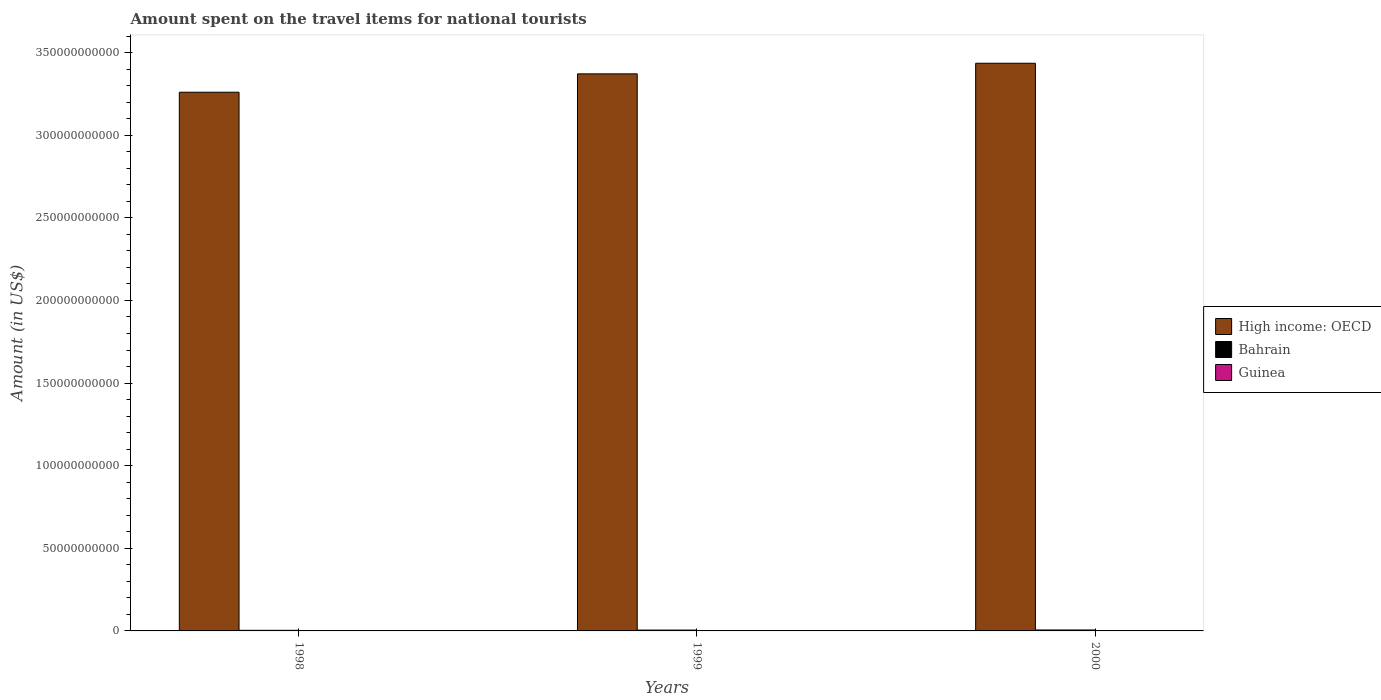How many different coloured bars are there?
Offer a terse response. 3. Are the number of bars per tick equal to the number of legend labels?
Your response must be concise. Yes. Are the number of bars on each tick of the X-axis equal?
Provide a short and direct response. Yes. In how many cases, is the number of bars for a given year not equal to the number of legend labels?
Offer a terse response. 0. What is the amount spent on the travel items for national tourists in Bahrain in 1999?
Ensure brevity in your answer.  5.18e+08. Across all years, what is the maximum amount spent on the travel items for national tourists in Guinea?
Give a very brief answer. 2.00e+06. What is the total amount spent on the travel items for national tourists in Bahrain in the graph?
Provide a short and direct response. 1.46e+09. What is the difference between the amount spent on the travel items for national tourists in Bahrain in 1999 and that in 2000?
Ensure brevity in your answer.  -5.50e+07. What is the difference between the amount spent on the travel items for national tourists in Bahrain in 2000 and the amount spent on the travel items for national tourists in Guinea in 1999?
Offer a terse response. 5.71e+08. What is the average amount spent on the travel items for national tourists in Bahrain per year?
Provide a succinct answer. 4.86e+08. In the year 1998, what is the difference between the amount spent on the travel items for national tourists in Guinea and amount spent on the travel items for national tourists in Bahrain?
Keep it short and to the point. -3.65e+08. In how many years, is the amount spent on the travel items for national tourists in High income: OECD greater than 300000000000 US$?
Keep it short and to the point. 3. What is the ratio of the amount spent on the travel items for national tourists in Bahrain in 1999 to that in 2000?
Keep it short and to the point. 0.9. What is the difference between the highest and the second highest amount spent on the travel items for national tourists in High income: OECD?
Offer a terse response. 6.42e+09. What is the difference between the highest and the lowest amount spent on the travel items for national tourists in Bahrain?
Provide a succinct answer. 2.07e+08. In how many years, is the amount spent on the travel items for national tourists in Guinea greater than the average amount spent on the travel items for national tourists in Guinea taken over all years?
Offer a very short reply. 2. What does the 1st bar from the left in 1999 represents?
Keep it short and to the point. High income: OECD. What does the 1st bar from the right in 2000 represents?
Your answer should be compact. Guinea. Is it the case that in every year, the sum of the amount spent on the travel items for national tourists in Guinea and amount spent on the travel items for national tourists in High income: OECD is greater than the amount spent on the travel items for national tourists in Bahrain?
Offer a terse response. Yes. How many bars are there?
Your response must be concise. 9. Are all the bars in the graph horizontal?
Offer a very short reply. No. How many years are there in the graph?
Keep it short and to the point. 3. What is the difference between two consecutive major ticks on the Y-axis?
Offer a very short reply. 5.00e+1. Are the values on the major ticks of Y-axis written in scientific E-notation?
Ensure brevity in your answer.  No. Does the graph contain any zero values?
Ensure brevity in your answer.  No. Does the graph contain grids?
Provide a succinct answer. No. How many legend labels are there?
Ensure brevity in your answer.  3. What is the title of the graph?
Your answer should be very brief. Amount spent on the travel items for national tourists. Does "Cabo Verde" appear as one of the legend labels in the graph?
Ensure brevity in your answer.  No. What is the label or title of the X-axis?
Ensure brevity in your answer.  Years. What is the Amount (in US$) in High income: OECD in 1998?
Offer a very short reply. 3.26e+11. What is the Amount (in US$) of Bahrain in 1998?
Offer a very short reply. 3.66e+08. What is the Amount (in US$) of High income: OECD in 1999?
Ensure brevity in your answer.  3.37e+11. What is the Amount (in US$) of Bahrain in 1999?
Provide a short and direct response. 5.18e+08. What is the Amount (in US$) of Guinea in 1999?
Offer a very short reply. 1.70e+06. What is the Amount (in US$) in High income: OECD in 2000?
Keep it short and to the point. 3.44e+11. What is the Amount (in US$) in Bahrain in 2000?
Offer a terse response. 5.73e+08. Across all years, what is the maximum Amount (in US$) in High income: OECD?
Your answer should be compact. 3.44e+11. Across all years, what is the maximum Amount (in US$) of Bahrain?
Offer a very short reply. 5.73e+08. Across all years, what is the maximum Amount (in US$) of Guinea?
Offer a very short reply. 2.00e+06. Across all years, what is the minimum Amount (in US$) of High income: OECD?
Provide a succinct answer. 3.26e+11. Across all years, what is the minimum Amount (in US$) of Bahrain?
Ensure brevity in your answer.  3.66e+08. Across all years, what is the minimum Amount (in US$) in Guinea?
Offer a terse response. 9.00e+05. What is the total Amount (in US$) in High income: OECD in the graph?
Keep it short and to the point. 1.01e+12. What is the total Amount (in US$) of Bahrain in the graph?
Offer a terse response. 1.46e+09. What is the total Amount (in US$) of Guinea in the graph?
Offer a terse response. 4.60e+06. What is the difference between the Amount (in US$) of High income: OECD in 1998 and that in 1999?
Provide a short and direct response. -1.11e+1. What is the difference between the Amount (in US$) in Bahrain in 1998 and that in 1999?
Give a very brief answer. -1.52e+08. What is the difference between the Amount (in US$) of Guinea in 1998 and that in 1999?
Offer a very short reply. -8.00e+05. What is the difference between the Amount (in US$) of High income: OECD in 1998 and that in 2000?
Provide a short and direct response. -1.75e+1. What is the difference between the Amount (in US$) in Bahrain in 1998 and that in 2000?
Provide a succinct answer. -2.07e+08. What is the difference between the Amount (in US$) in Guinea in 1998 and that in 2000?
Offer a terse response. -1.10e+06. What is the difference between the Amount (in US$) in High income: OECD in 1999 and that in 2000?
Your response must be concise. -6.42e+09. What is the difference between the Amount (in US$) in Bahrain in 1999 and that in 2000?
Keep it short and to the point. -5.50e+07. What is the difference between the Amount (in US$) of Guinea in 1999 and that in 2000?
Make the answer very short. -3.00e+05. What is the difference between the Amount (in US$) of High income: OECD in 1998 and the Amount (in US$) of Bahrain in 1999?
Make the answer very short. 3.25e+11. What is the difference between the Amount (in US$) of High income: OECD in 1998 and the Amount (in US$) of Guinea in 1999?
Provide a succinct answer. 3.26e+11. What is the difference between the Amount (in US$) of Bahrain in 1998 and the Amount (in US$) of Guinea in 1999?
Offer a very short reply. 3.64e+08. What is the difference between the Amount (in US$) of High income: OECD in 1998 and the Amount (in US$) of Bahrain in 2000?
Give a very brief answer. 3.25e+11. What is the difference between the Amount (in US$) of High income: OECD in 1998 and the Amount (in US$) of Guinea in 2000?
Provide a short and direct response. 3.26e+11. What is the difference between the Amount (in US$) of Bahrain in 1998 and the Amount (in US$) of Guinea in 2000?
Your answer should be compact. 3.64e+08. What is the difference between the Amount (in US$) of High income: OECD in 1999 and the Amount (in US$) of Bahrain in 2000?
Ensure brevity in your answer.  3.37e+11. What is the difference between the Amount (in US$) in High income: OECD in 1999 and the Amount (in US$) in Guinea in 2000?
Keep it short and to the point. 3.37e+11. What is the difference between the Amount (in US$) of Bahrain in 1999 and the Amount (in US$) of Guinea in 2000?
Give a very brief answer. 5.16e+08. What is the average Amount (in US$) in High income: OECD per year?
Give a very brief answer. 3.36e+11. What is the average Amount (in US$) in Bahrain per year?
Your answer should be very brief. 4.86e+08. What is the average Amount (in US$) of Guinea per year?
Provide a short and direct response. 1.53e+06. In the year 1998, what is the difference between the Amount (in US$) of High income: OECD and Amount (in US$) of Bahrain?
Your answer should be very brief. 3.26e+11. In the year 1998, what is the difference between the Amount (in US$) in High income: OECD and Amount (in US$) in Guinea?
Your response must be concise. 3.26e+11. In the year 1998, what is the difference between the Amount (in US$) in Bahrain and Amount (in US$) in Guinea?
Offer a very short reply. 3.65e+08. In the year 1999, what is the difference between the Amount (in US$) in High income: OECD and Amount (in US$) in Bahrain?
Your answer should be very brief. 3.37e+11. In the year 1999, what is the difference between the Amount (in US$) in High income: OECD and Amount (in US$) in Guinea?
Your response must be concise. 3.37e+11. In the year 1999, what is the difference between the Amount (in US$) of Bahrain and Amount (in US$) of Guinea?
Your answer should be very brief. 5.16e+08. In the year 2000, what is the difference between the Amount (in US$) in High income: OECD and Amount (in US$) in Bahrain?
Provide a short and direct response. 3.43e+11. In the year 2000, what is the difference between the Amount (in US$) of High income: OECD and Amount (in US$) of Guinea?
Offer a terse response. 3.44e+11. In the year 2000, what is the difference between the Amount (in US$) in Bahrain and Amount (in US$) in Guinea?
Ensure brevity in your answer.  5.71e+08. What is the ratio of the Amount (in US$) of High income: OECD in 1998 to that in 1999?
Your response must be concise. 0.97. What is the ratio of the Amount (in US$) in Bahrain in 1998 to that in 1999?
Provide a succinct answer. 0.71. What is the ratio of the Amount (in US$) in Guinea in 1998 to that in 1999?
Make the answer very short. 0.53. What is the ratio of the Amount (in US$) in High income: OECD in 1998 to that in 2000?
Your answer should be very brief. 0.95. What is the ratio of the Amount (in US$) of Bahrain in 1998 to that in 2000?
Your answer should be compact. 0.64. What is the ratio of the Amount (in US$) of Guinea in 1998 to that in 2000?
Ensure brevity in your answer.  0.45. What is the ratio of the Amount (in US$) in High income: OECD in 1999 to that in 2000?
Provide a succinct answer. 0.98. What is the ratio of the Amount (in US$) of Bahrain in 1999 to that in 2000?
Make the answer very short. 0.9. What is the ratio of the Amount (in US$) in Guinea in 1999 to that in 2000?
Offer a very short reply. 0.85. What is the difference between the highest and the second highest Amount (in US$) of High income: OECD?
Your response must be concise. 6.42e+09. What is the difference between the highest and the second highest Amount (in US$) of Bahrain?
Provide a succinct answer. 5.50e+07. What is the difference between the highest and the lowest Amount (in US$) in High income: OECD?
Your answer should be very brief. 1.75e+1. What is the difference between the highest and the lowest Amount (in US$) of Bahrain?
Ensure brevity in your answer.  2.07e+08. What is the difference between the highest and the lowest Amount (in US$) of Guinea?
Ensure brevity in your answer.  1.10e+06. 